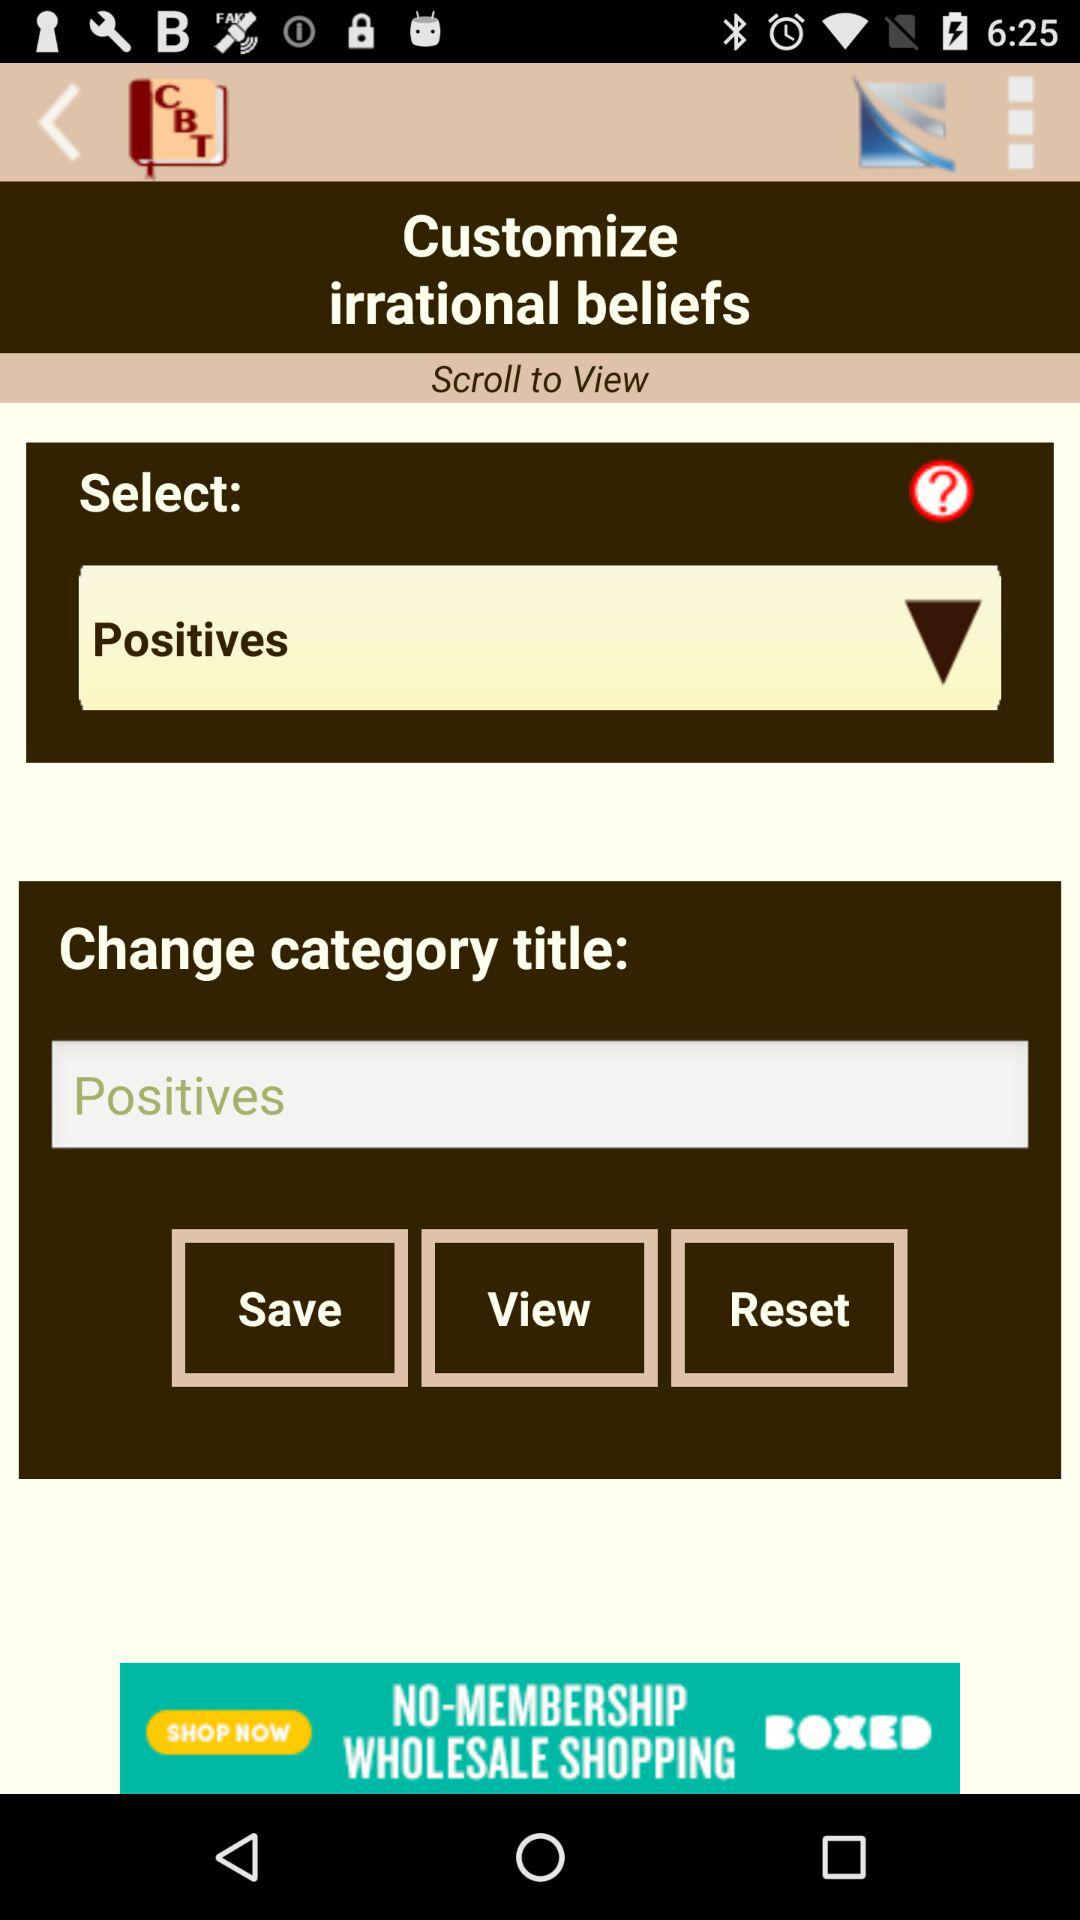What is the category title? The category title is "Positives". 